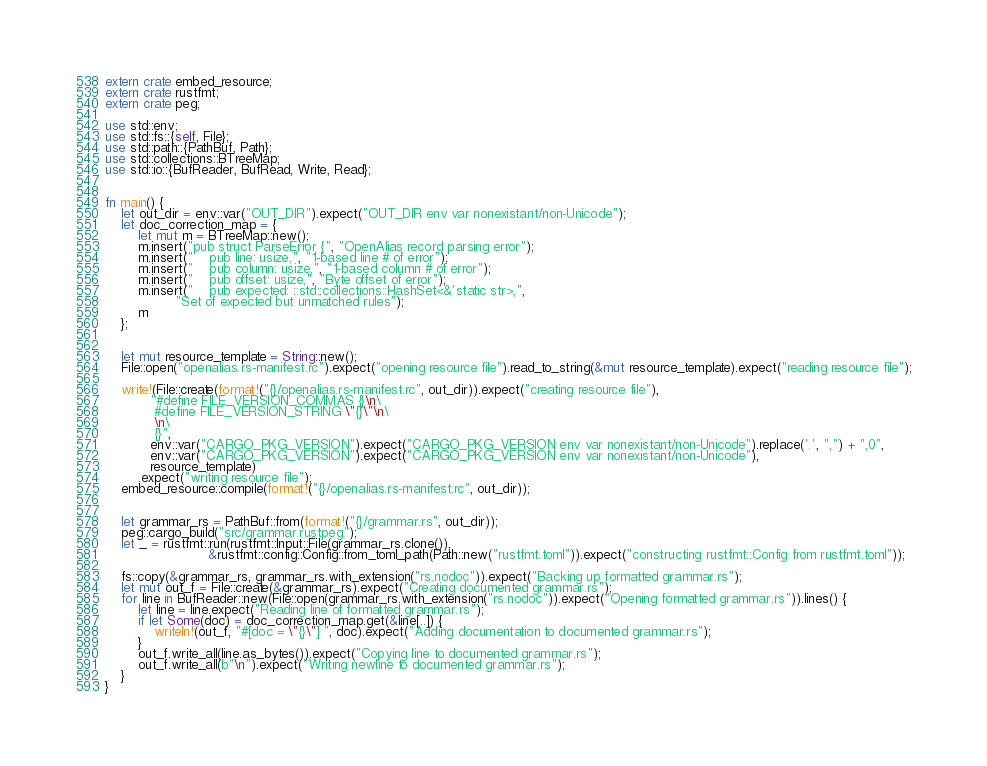<code> <loc_0><loc_0><loc_500><loc_500><_Rust_>extern crate embed_resource;
extern crate rustfmt;
extern crate peg;

use std::env;
use std::fs::{self, File};
use std::path::{PathBuf, Path};
use std::collections::BTreeMap;
use std::io::{BufReader, BufRead, Write, Read};


fn main() {
    let out_dir = env::var("OUT_DIR").expect("OUT_DIR env var nonexistant/non-Unicode");
    let doc_correction_map = {
        let mut m = BTreeMap::new();
        m.insert("pub struct ParseError {", "OpenAlias record parsing error");
        m.insert("    pub line: usize,", "1-based line # of error");
        m.insert("    pub column: usize,", "1-based column # of error");
        m.insert("    pub offset: usize,", "Byte offset of error");
        m.insert("    pub expected: ::std::collections::HashSet<&'static str>,",
                 "Set of expected but unmatched rules");
        m
    };


    let mut resource_template = String::new();
    File::open("openalias.rs-manifest.rc").expect("opening resource file").read_to_string(&mut resource_template).expect("reading resource file");

    write!(File::create(format!("{}/openalias.rs-manifest.rc", out_dir)).expect("creating resource file"),
           "#define FILE_VERSION_COMMAS {}\n\
            #define FILE_VERSION_STRING \"{}\"\n\
            \n\
            {}",
           env::var("CARGO_PKG_VERSION").expect("CARGO_PKG_VERSION env var nonexistant/non-Unicode").replace('.', ",") + ",0",
           env::var("CARGO_PKG_VERSION").expect("CARGO_PKG_VERSION env var nonexistant/non-Unicode"),
           resource_template)
        .expect("writing resource file");
    embed_resource::compile(format!("{}/openalias.rs-manifest.rc", out_dir));


    let grammar_rs = PathBuf::from(format!("{}/grammar.rs", out_dir));
    peg::cargo_build("src/grammar.rustpeg");
    let _ = rustfmt::run(rustfmt::Input::File(grammar_rs.clone()),
                         &rustfmt::config::Config::from_toml_path(Path::new("rustfmt.toml")).expect("constructing rustfmt::Config from rustfmt.toml"));

    fs::copy(&grammar_rs, grammar_rs.with_extension("rs.nodoc")).expect("Backing up formatted grammar.rs");
    let mut out_f = File::create(&grammar_rs).expect("Creating documented grammar.rs");
    for line in BufReader::new(File::open(grammar_rs.with_extension("rs.nodoc")).expect("Opening formatted grammar.rs")).lines() {
        let line = line.expect("Reading line of formatted grammar.rs");
        if let Some(doc) = doc_correction_map.get(&line[..]) {
            writeln!(out_f, "#[doc = \"{}\"] ", doc).expect("Adding documentation to documented grammar.rs");
        }
        out_f.write_all(line.as_bytes()).expect("Copying line to documented grammar.rs");
        out_f.write_all(b"\n").expect("Writing newline to documented grammar.rs");
    }
}
</code> 